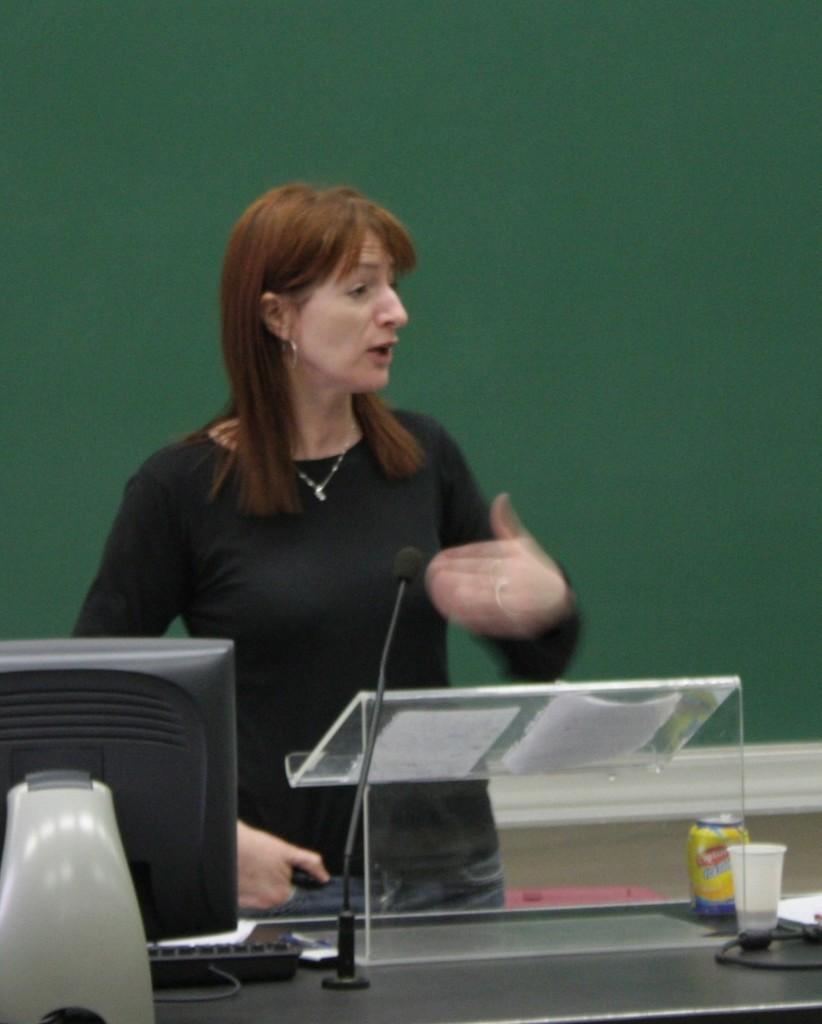Describe this image in one or two sentences. In this image we can see a woman standing beside a table containing a monitor, keyboard, a speaker stand with some papers on it, a mic with a stand, a tin, glass and a wire which are placed on it. On the backside we can see a wall. 